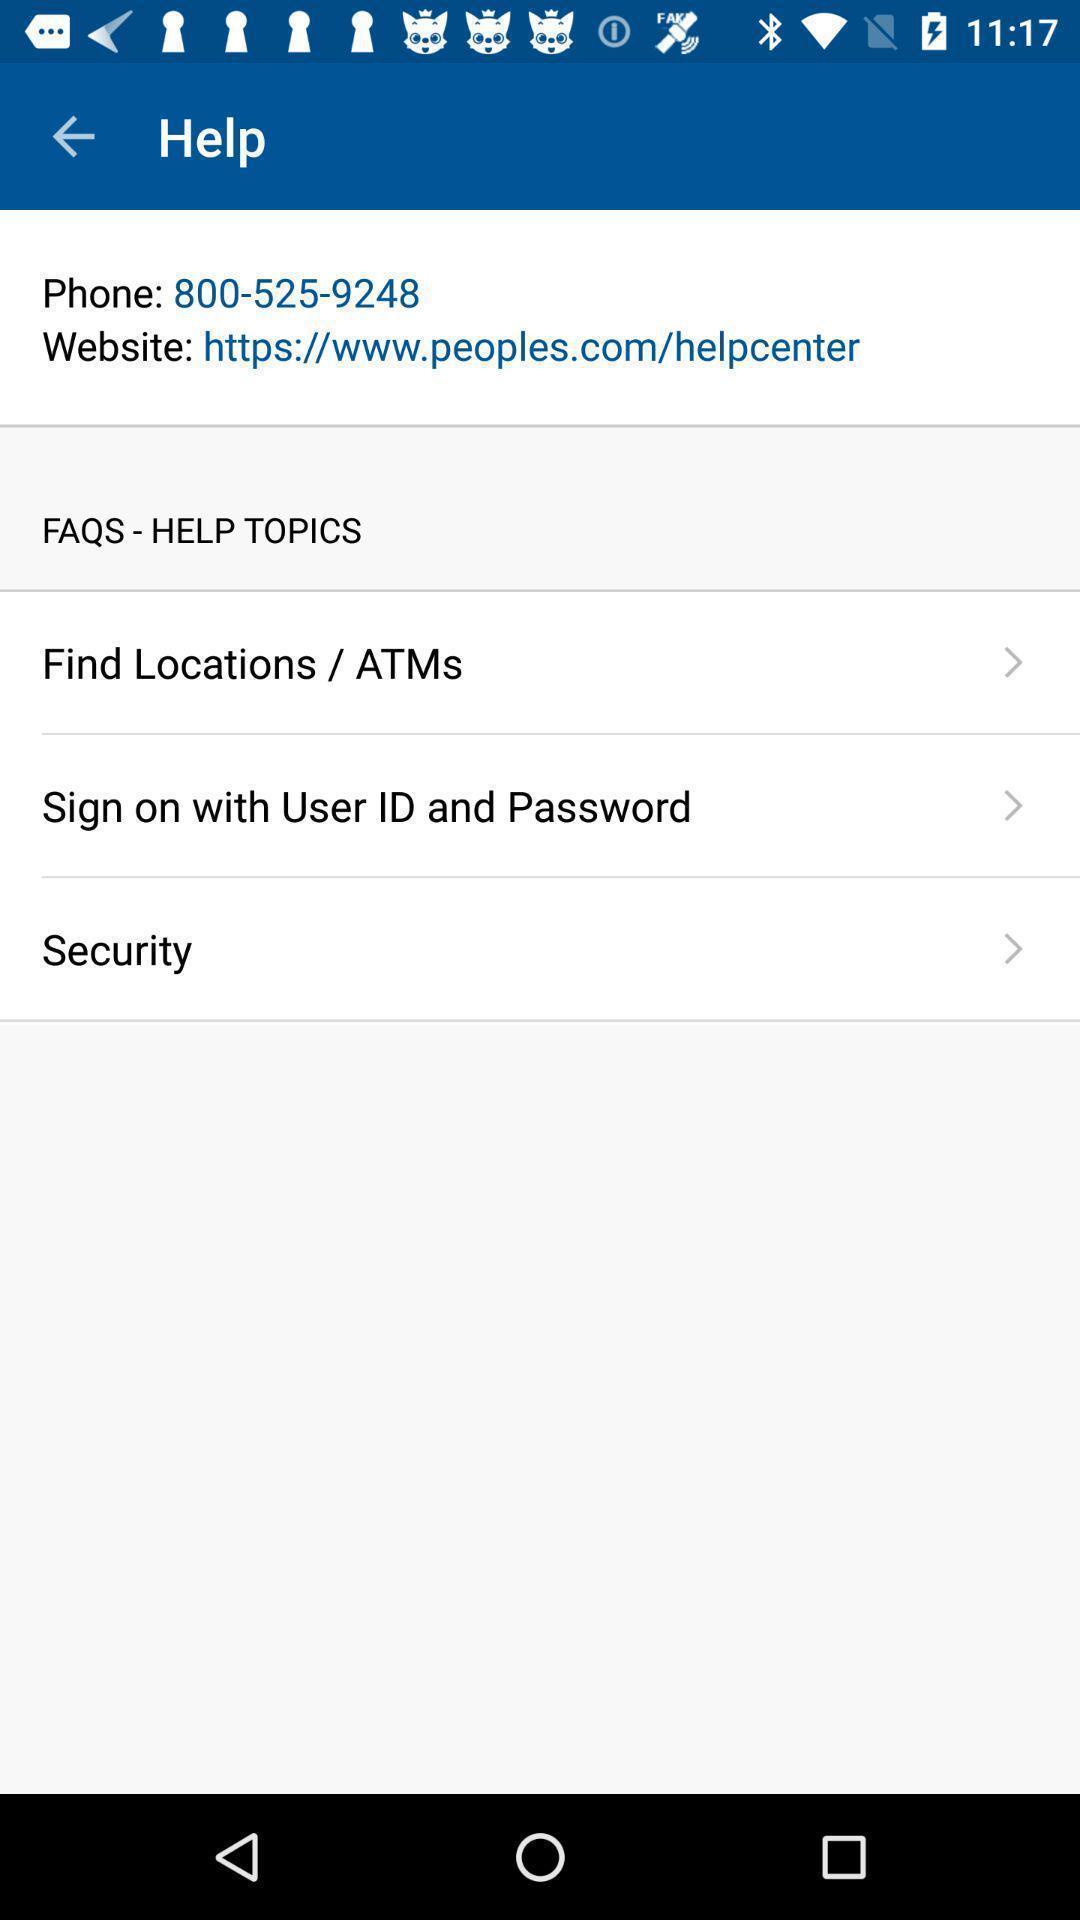Describe the key features of this screenshot. Sign in page of a account setting applications. 